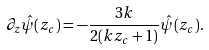Convert formula to latex. <formula><loc_0><loc_0><loc_500><loc_500>\partial _ { z } \hat { \psi } ( z _ { c } ) = - \frac { 3 k } { 2 ( k z _ { c } + 1 ) } \hat { \psi } ( z _ { c } ) .</formula> 